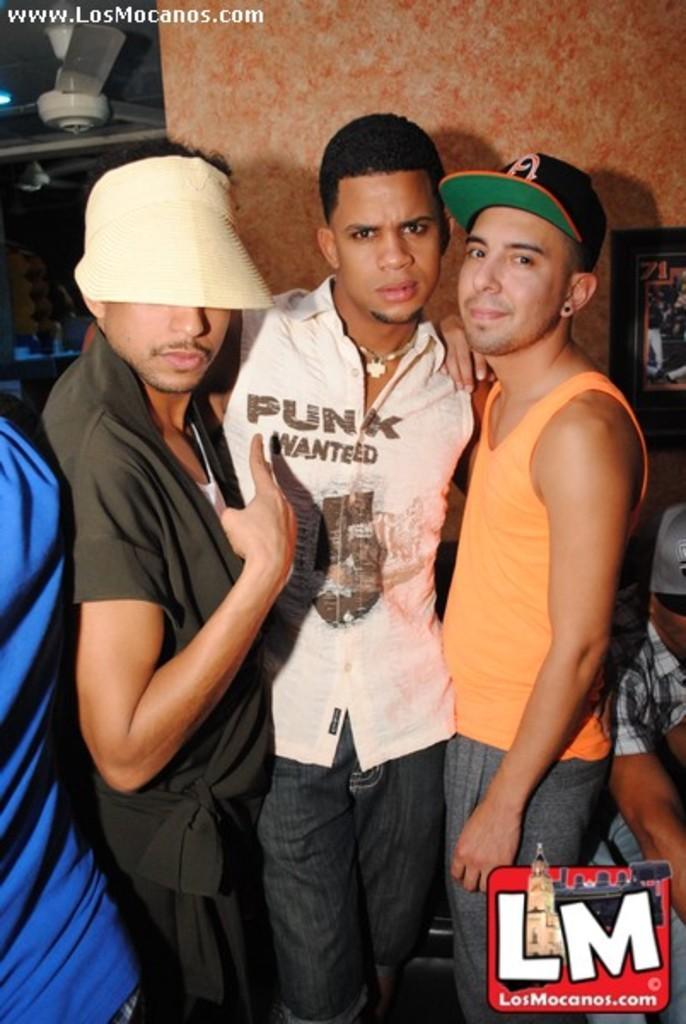Could you give a brief overview of what you see in this image? In the picture I can see three men standing on the floor. There is a man on the right side and looks like he is sitting on the chair. There is a fan on the roof on the top left side. I can see a photo frame on the wall on the right side. 